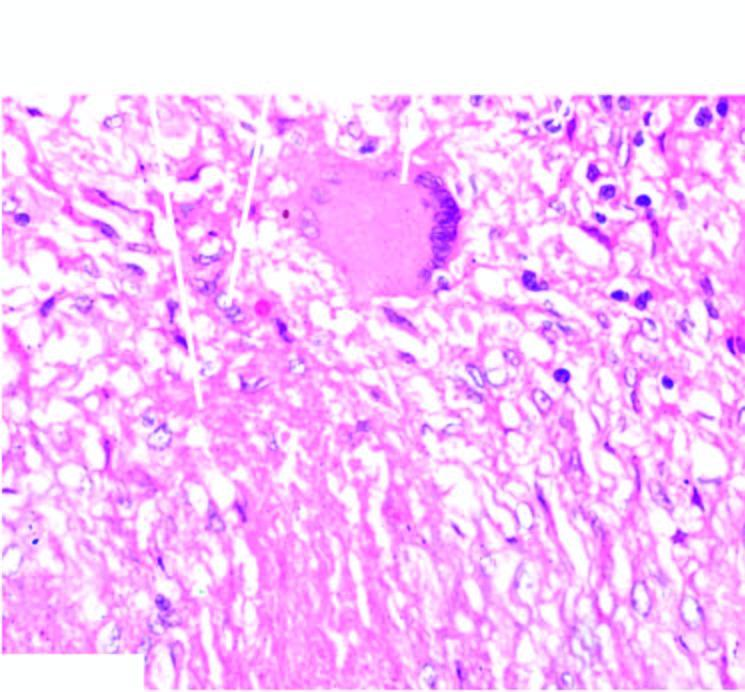s there central caseation necrosis, surrounded by elongated epithelioid cells having characteristic slipper-shaped nuclei, with interspersed langhans ' giant cells?
Answer the question using a single word or phrase. Yes 